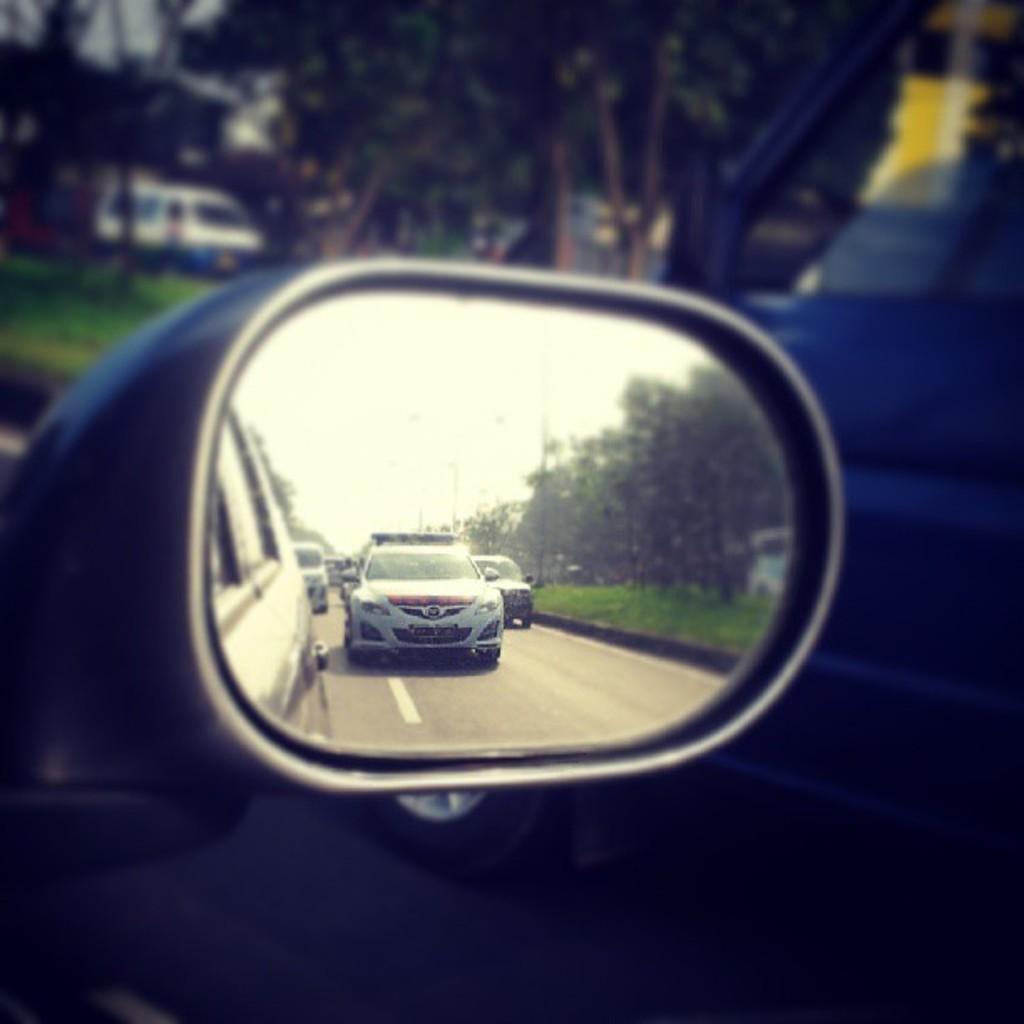Could you give a brief overview of what you see in this image? In the image we can see there is a side window of the car and in the side mirror there are cars parked on the road. Behind there are trees and the background is blurred. 